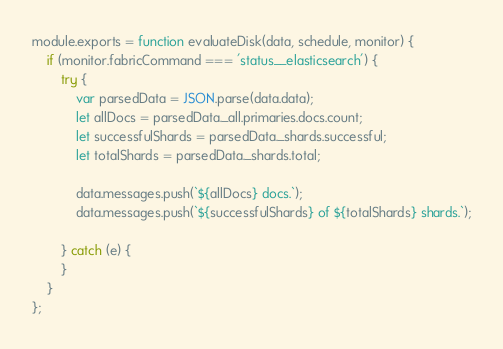Convert code to text. <code><loc_0><loc_0><loc_500><loc_500><_JavaScript_>module.exports = function evaluateDisk(data, schedule, monitor) {
	if (monitor.fabricCommand === 'status__elasticsearch') {
		try {
			var parsedData = JSON.parse(data.data);
			let allDocs = parsedData._all.primaries.docs.count;
			let successfulShards = parsedData._shards.successful;
			let totalShards = parsedData._shards.total;

			data.messages.push(`${allDocs} docs.`);
			data.messages.push(`${successfulShards} of ${totalShards} shards.`);

		} catch (e) {
		}
	}
};
</code> 